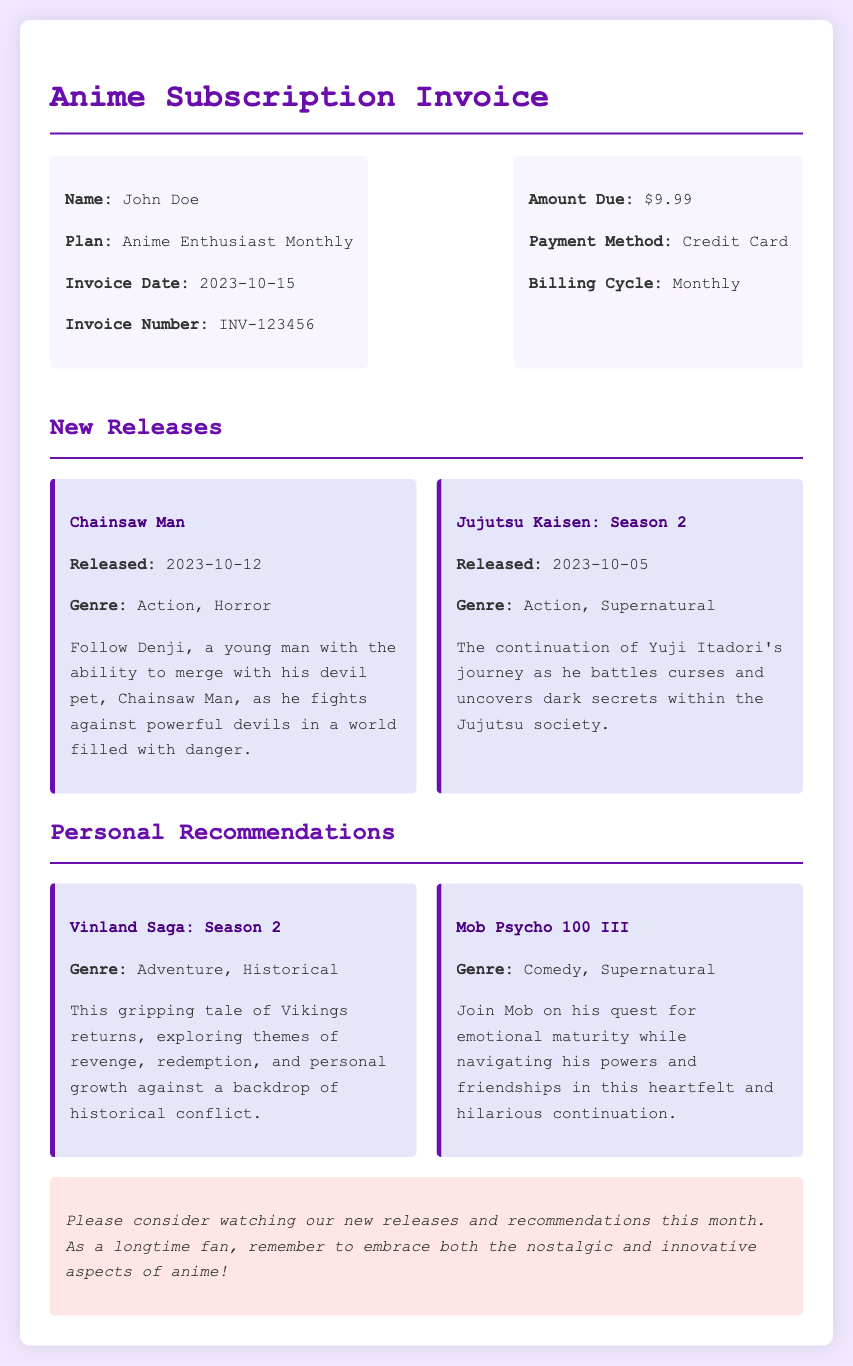what is the name of the subscriber? The subscriber's name is listed in the invoice header section.
Answer: John Doe what is the plan type? The plan type is specified in the invoice details.
Answer: Anime Enthusiast Monthly what is the invoice date? The invoice date is directly mentioned in the details of the invoice.
Answer: 2023-10-15 what is the amount due? The amount due is clearly stated in the billing details section.
Answer: $9.99 which anime was released on 2023-10-12? The anime release date corresponds to the title provided in the new releases section.
Answer: Chainsaw Man what genre is Jujutsu Kaisen: Season 2? The genre is listed under the details for the specific anime in the document.
Answer: Action, Supernatural which anime is recommended for historical adventure? This requires reasoning over the recommendations provided in the document.
Answer: Vinland Saga: Season 2 how many new releases are mentioned in the document? The number of new releases can be counted from the section that lists them.
Answer: 2 what payment method is used for the subscription? The payment method is specified in the billing details.
Answer: Credit Card 